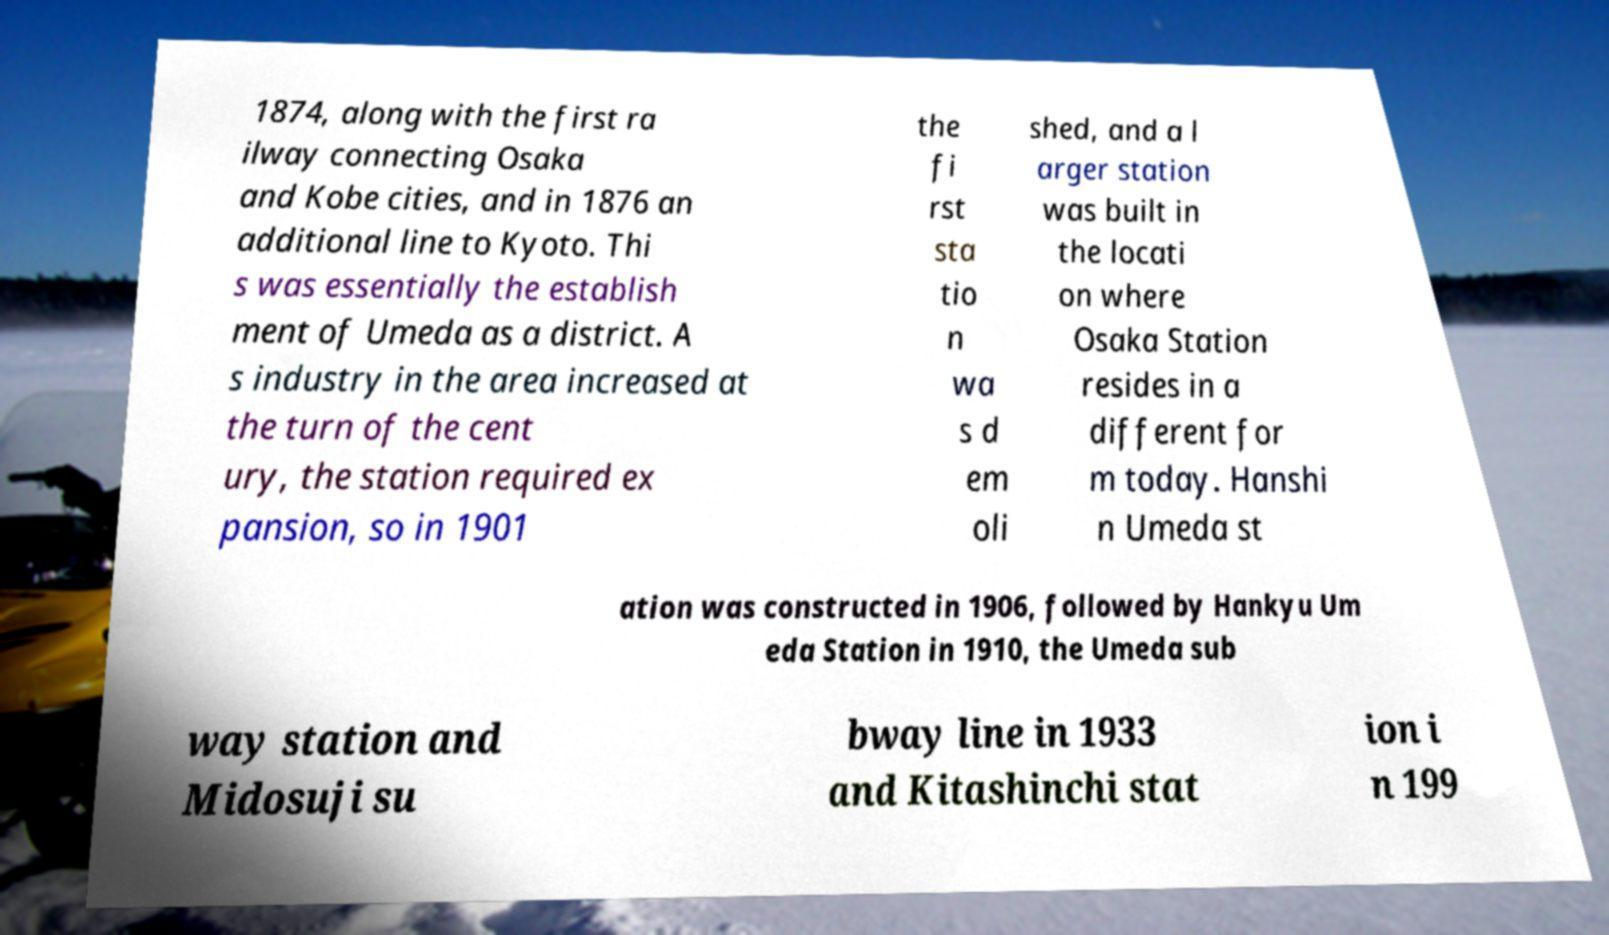I need the written content from this picture converted into text. Can you do that? 1874, along with the first ra ilway connecting Osaka and Kobe cities, and in 1876 an additional line to Kyoto. Thi s was essentially the establish ment of Umeda as a district. A s industry in the area increased at the turn of the cent ury, the station required ex pansion, so in 1901 the fi rst sta tio n wa s d em oli shed, and a l arger station was built in the locati on where Osaka Station resides in a different for m today. Hanshi n Umeda st ation was constructed in 1906, followed by Hankyu Um eda Station in 1910, the Umeda sub way station and Midosuji su bway line in 1933 and Kitashinchi stat ion i n 199 